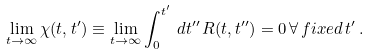Convert formula to latex. <formula><loc_0><loc_0><loc_500><loc_500>\lim _ { t \rightarrow \infty } \chi ( t , t ^ { \prime } ) \equiv \lim _ { t \rightarrow \infty } \int _ { 0 } ^ { t ^ { \prime } } \, d t ^ { \prime \prime } \, R ( t , t ^ { \prime \prime } ) = 0 \, \forall \, f i x e d \, t ^ { \prime } \, .</formula> 